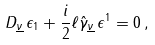<formula> <loc_0><loc_0><loc_500><loc_500>D _ { \underline { \nu } } \, \epsilon _ { 1 } + \frac { i } { 2 } \ell \hat { \gamma } _ { \underline { \nu } } \, \epsilon ^ { 1 } = 0 \, ,</formula> 